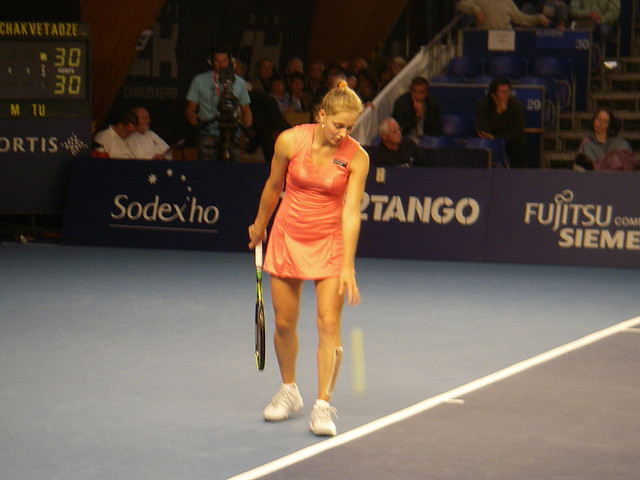Please transcribe the text in this image. Sodexho TANGO FUJITSU SIEME 30 CHAKVETADZE 30 TU M ORTIS 